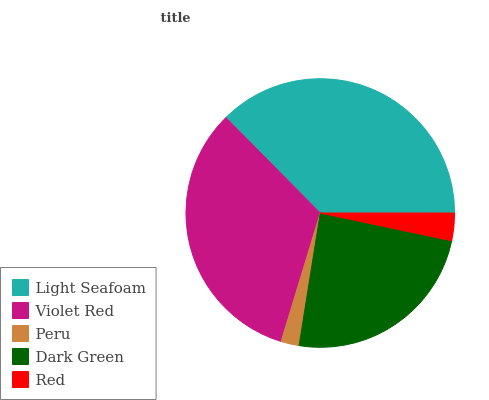Is Peru the minimum?
Answer yes or no. Yes. Is Light Seafoam the maximum?
Answer yes or no. Yes. Is Violet Red the minimum?
Answer yes or no. No. Is Violet Red the maximum?
Answer yes or no. No. Is Light Seafoam greater than Violet Red?
Answer yes or no. Yes. Is Violet Red less than Light Seafoam?
Answer yes or no. Yes. Is Violet Red greater than Light Seafoam?
Answer yes or no. No. Is Light Seafoam less than Violet Red?
Answer yes or no. No. Is Dark Green the high median?
Answer yes or no. Yes. Is Dark Green the low median?
Answer yes or no. Yes. Is Light Seafoam the high median?
Answer yes or no. No. Is Red the low median?
Answer yes or no. No. 